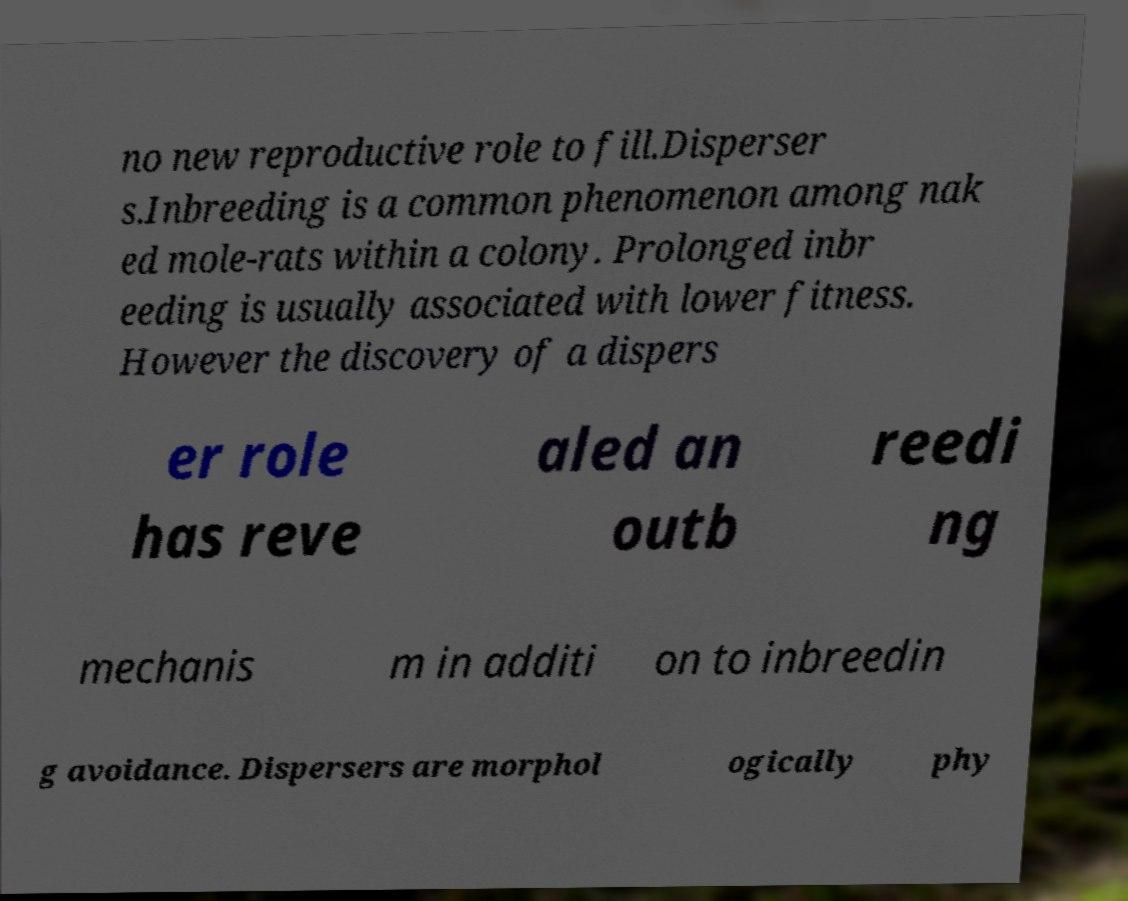Can you read and provide the text displayed in the image?This photo seems to have some interesting text. Can you extract and type it out for me? no new reproductive role to fill.Disperser s.Inbreeding is a common phenomenon among nak ed mole-rats within a colony. Prolonged inbr eeding is usually associated with lower fitness. However the discovery of a dispers er role has reve aled an outb reedi ng mechanis m in additi on to inbreedin g avoidance. Dispersers are morphol ogically phy 